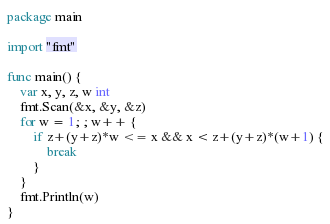Convert code to text. <code><loc_0><loc_0><loc_500><loc_500><_Go_>package main

import "fmt"

func main() {
	var x, y, z, w int
	fmt.Scan(&x, &y, &z)
	for w = 1; ; w++ {
		if z+(y+z)*w <= x && x < z+(y+z)*(w+1) {
			break
		}
	}
	fmt.Println(w)
}
</code> 